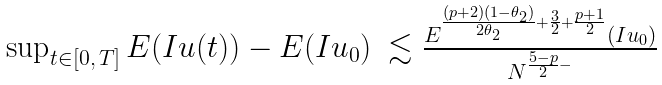<formula> <loc_0><loc_0><loc_500><loc_500>\begin{array} { l l } \sup _ { t \in [ 0 , \, T ] } E ( I u ( t ) ) - E ( I u _ { 0 } ) & \lesssim \frac { E ^ { \frac { ( p + 2 ) ( 1 - \theta _ { 2 } ) } { 2 \theta _ { 2 } } + \frac { 3 } { 2 } + \frac { p + 1 } { 2 } } ( I u _ { 0 } ) } { N ^ { \frac { 5 - p } { 2 } - } } \end{array}</formula> 